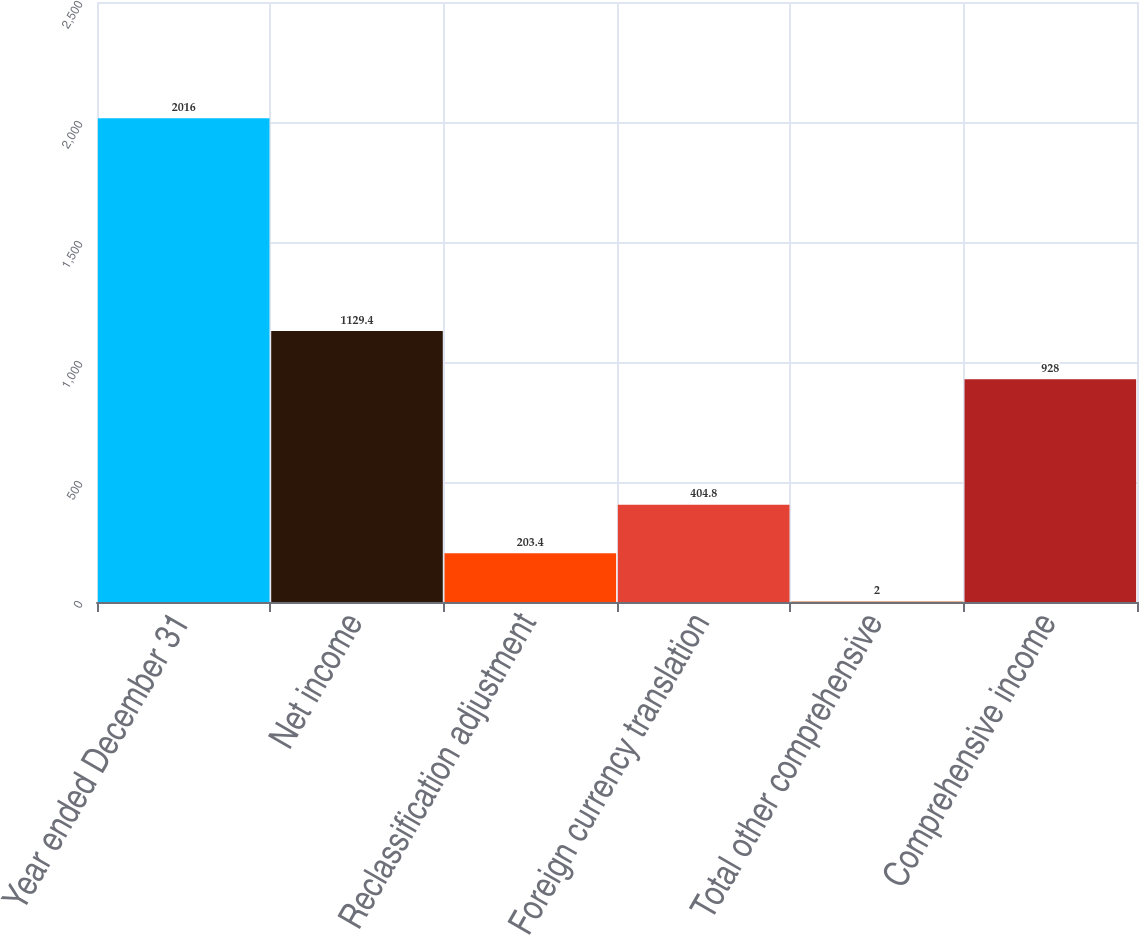Convert chart. <chart><loc_0><loc_0><loc_500><loc_500><bar_chart><fcel>Year ended December 31<fcel>Net income<fcel>Reclassification adjustment<fcel>Foreign currency translation<fcel>Total other comprehensive<fcel>Comprehensive income<nl><fcel>2016<fcel>1129.4<fcel>203.4<fcel>404.8<fcel>2<fcel>928<nl></chart> 